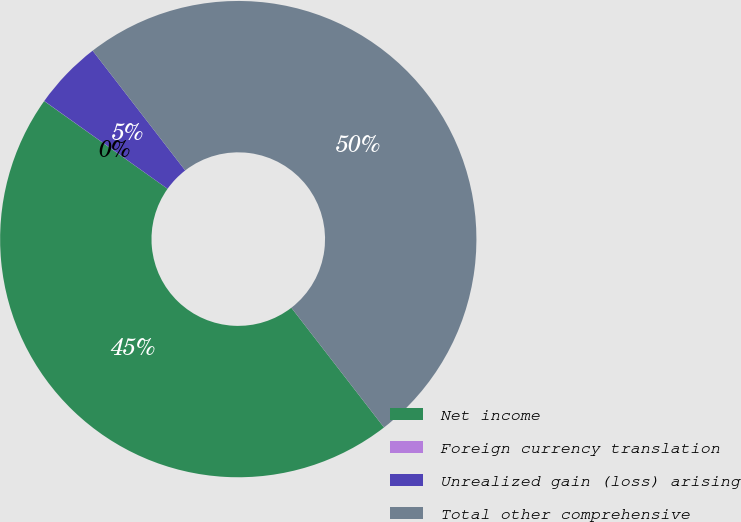Convert chart to OTSL. <chart><loc_0><loc_0><loc_500><loc_500><pie_chart><fcel>Net income<fcel>Foreign currency translation<fcel>Unrealized gain (loss) arising<fcel>Total other comprehensive<nl><fcel>45.32%<fcel>0.01%<fcel>4.68%<fcel>49.99%<nl></chart> 